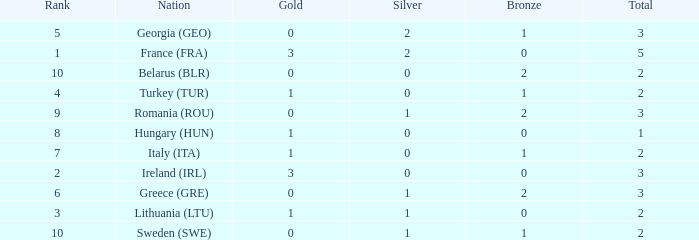What's the total of Sweden (SWE) having less than 1 silver? None. Would you be able to parse every entry in this table? {'header': ['Rank', 'Nation', 'Gold', 'Silver', 'Bronze', 'Total'], 'rows': [['5', 'Georgia (GEO)', '0', '2', '1', '3'], ['1', 'France (FRA)', '3', '2', '0', '5'], ['10', 'Belarus (BLR)', '0', '0', '2', '2'], ['4', 'Turkey (TUR)', '1', '0', '1', '2'], ['9', 'Romania (ROU)', '0', '1', '2', '3'], ['8', 'Hungary (HUN)', '1', '0', '0', '1'], ['7', 'Italy (ITA)', '1', '0', '1', '2'], ['2', 'Ireland (IRL)', '3', '0', '0', '3'], ['6', 'Greece (GRE)', '0', '1', '2', '3'], ['3', 'Lithuania (LTU)', '1', '1', '0', '2'], ['10', 'Sweden (SWE)', '0', '1', '1', '2']]} 